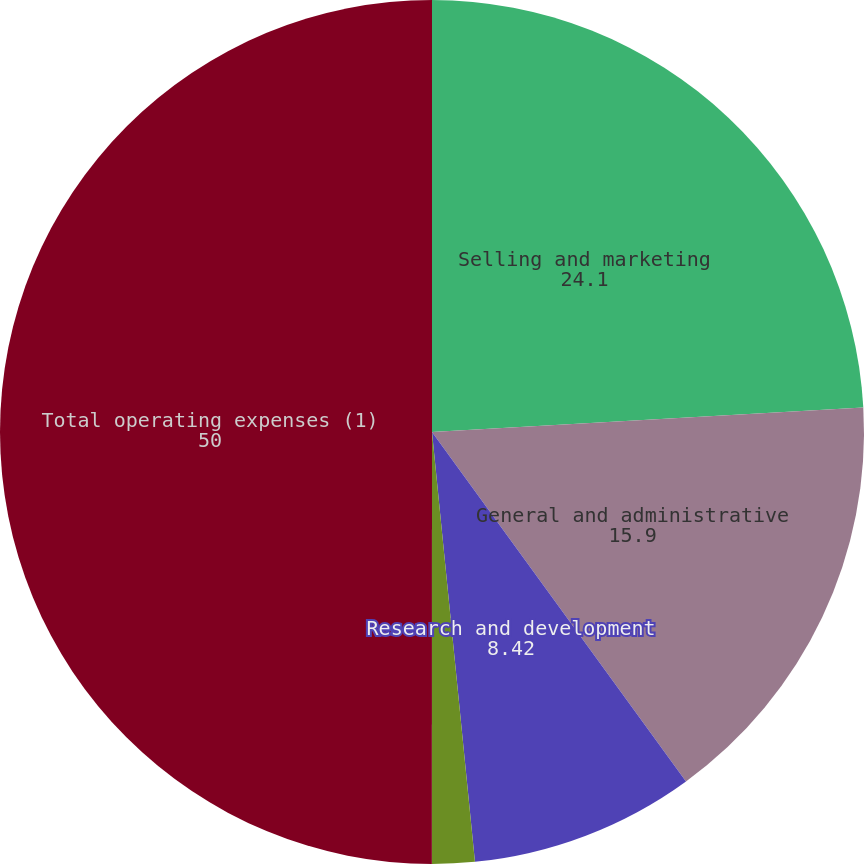<chart> <loc_0><loc_0><loc_500><loc_500><pie_chart><fcel>Selling and marketing<fcel>General and administrative<fcel>Research and development<fcel>Depreciation and amortization<fcel>Total operating expenses (1)<nl><fcel>24.1%<fcel>15.9%<fcel>8.42%<fcel>1.59%<fcel>50.0%<nl></chart> 